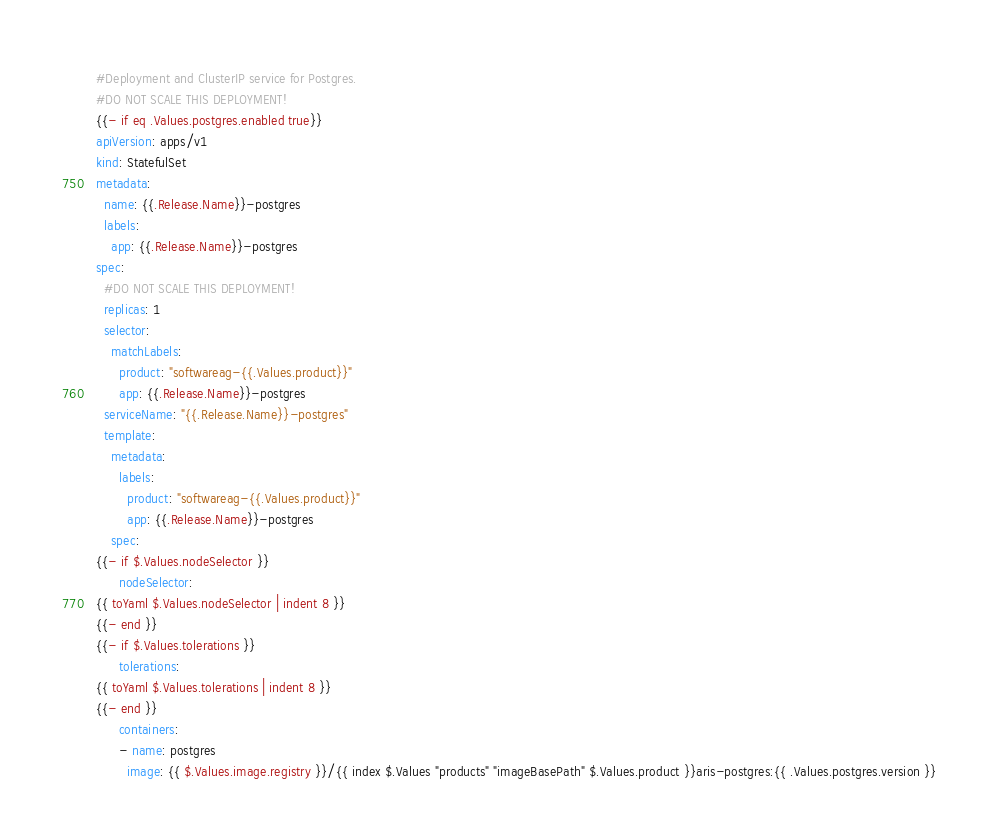Convert code to text. <code><loc_0><loc_0><loc_500><loc_500><_YAML_>#Deployment and ClusterIP service for Postgres. 
#DO NOT SCALE THIS DEPLOYMENT!
{{- if eq .Values.postgres.enabled true}}
apiVersion: apps/v1
kind: StatefulSet
metadata:
  name: {{.Release.Name}}-postgres
  labels:
    app: {{.Release.Name}}-postgres
spec:
  #DO NOT SCALE THIS DEPLOYMENT!
  replicas: 1
  selector:
    matchLabels:
      product: "softwareag-{{.Values.product}}"
      app: {{.Release.Name}}-postgres
  serviceName: "{{.Release.Name}}-postgres"
  template:
    metadata:
      labels:
        product: "softwareag-{{.Values.product}}"
        app: {{.Release.Name}}-postgres
    spec:
{{- if $.Values.nodeSelector }}
      nodeSelector:
{{ toYaml $.Values.nodeSelector | indent 8 }}
{{- end }}
{{- if $.Values.tolerations }}
      tolerations:
{{ toYaml $.Values.tolerations | indent 8 }}
{{- end }}
      containers:
      - name: postgres
        image: {{ $.Values.image.registry }}/{{ index $.Values "products" "imageBasePath" $.Values.product }}aris-postgres:{{ .Values.postgres.version }}</code> 